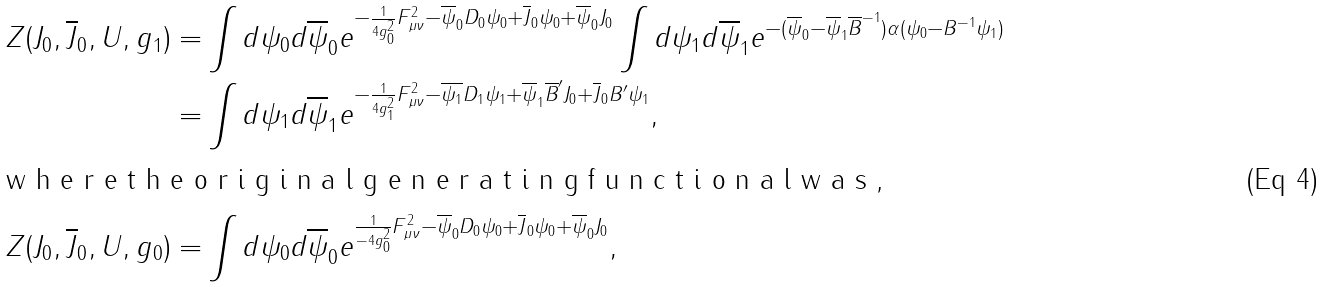<formula> <loc_0><loc_0><loc_500><loc_500>Z ( J _ { 0 } , \overline { J } _ { 0 } , U , g _ { 1 } ) = & \int d \psi _ { 0 } d \overline { \psi } _ { 0 } e ^ { - \frac { 1 } { 4 g _ { 0 } ^ { 2 } } F _ { \mu \nu } ^ { 2 } - \overline { \psi } _ { 0 } D _ { 0 } \psi _ { 0 } + \overline { J } _ { 0 } \psi _ { 0 } + \overline { \psi } _ { 0 } J _ { 0 } } \int d \psi _ { 1 } d \overline { \psi } _ { 1 } e ^ { - ( \overline { \psi } _ { 0 } - \overline { \psi } _ { 1 } \overline { B } ^ { - 1 } ) \alpha ( \psi _ { 0 } - B ^ { - 1 } \psi _ { 1 } ) } \\ = & \int d \psi _ { 1 } d \overline { \psi } _ { 1 } e ^ { - \frac { 1 } { 4 g _ { 1 } ^ { 2 } } F _ { \mu \nu } ^ { 2 } - \overline { \psi _ { 1 } } D _ { 1 } \psi _ { 1 } + \overline { \psi } _ { 1 } \overline { B } ^ { \prime } J _ { 0 } + \overline { J } _ { 0 } B ^ { \prime } \psi _ { 1 } } , \intertext { w h e r e t h e o r i g i n a l g e n e r a t i n g f u n c t i o n a l w a s , } Z ( J _ { 0 } , \overline { J } _ { 0 } , U , g _ { 0 } ) = & \int d \psi _ { 0 } d \overline { \psi } _ { 0 } e ^ { \frac { 1 } { - 4 g _ { 0 } ^ { 2 } } F _ { \mu \nu } ^ { 2 } - \overline { \psi } _ { 0 } D _ { 0 } \psi _ { 0 } + \overline { J } _ { 0 } \psi _ { 0 } + \overline { \psi } _ { 0 } J _ { 0 } } ,</formula> 